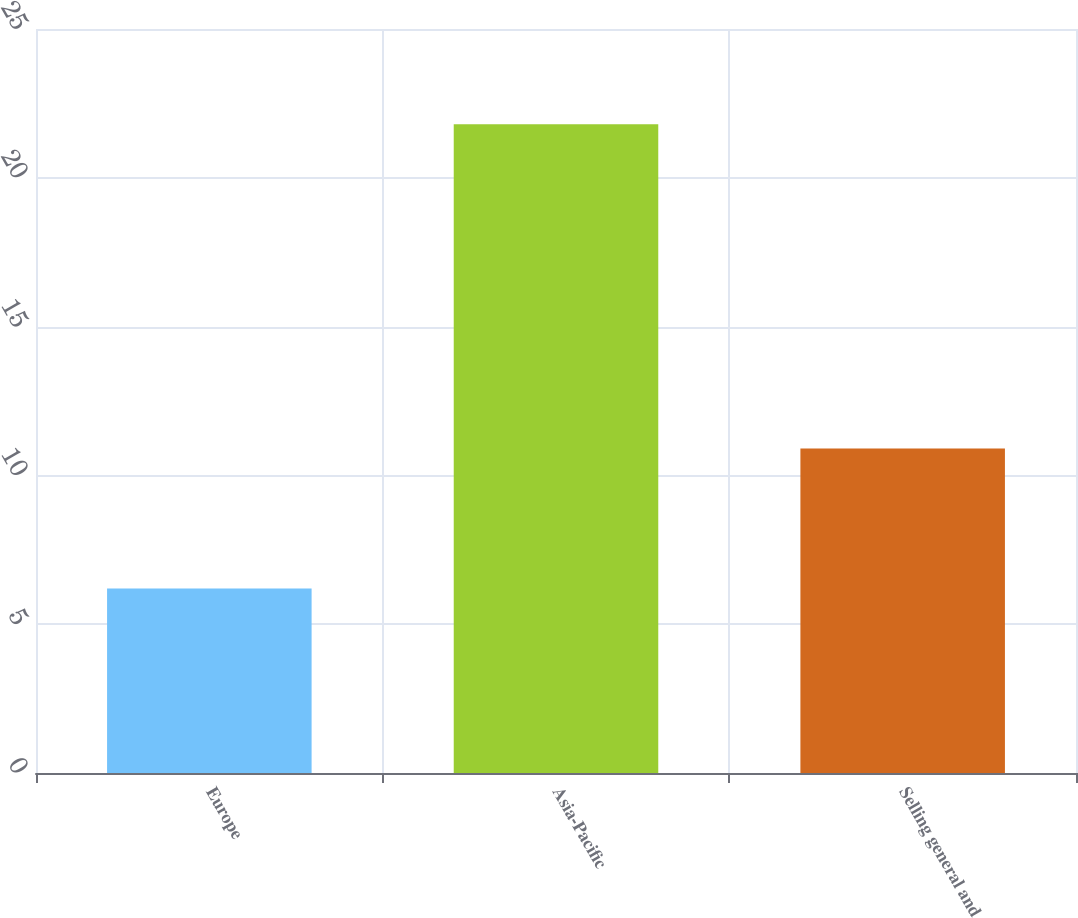<chart> <loc_0><loc_0><loc_500><loc_500><bar_chart><fcel>Europe<fcel>Asia-Pacific<fcel>Selling general and<nl><fcel>6.2<fcel>21.8<fcel>10.9<nl></chart> 